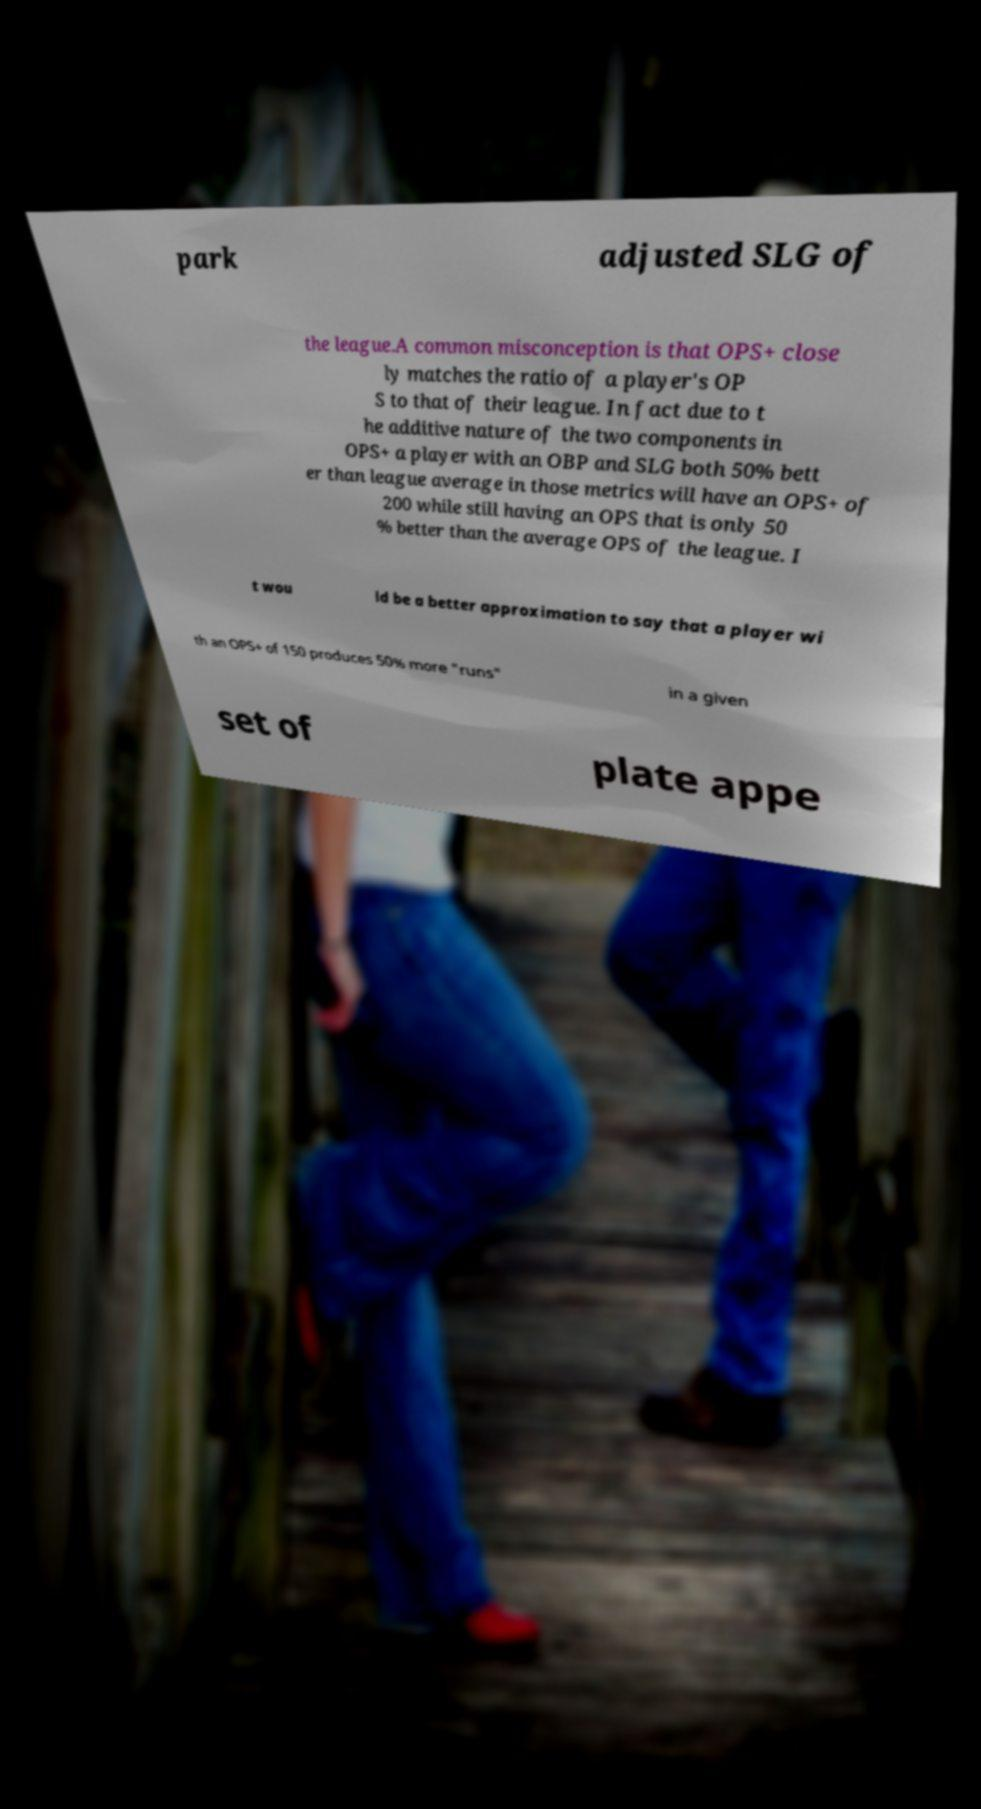Please read and relay the text visible in this image. What does it say? park adjusted SLG of the league.A common misconception is that OPS+ close ly matches the ratio of a player's OP S to that of their league. In fact due to t he additive nature of the two components in OPS+ a player with an OBP and SLG both 50% bett er than league average in those metrics will have an OPS+ of 200 while still having an OPS that is only 50 % better than the average OPS of the league. I t wou ld be a better approximation to say that a player wi th an OPS+ of 150 produces 50% more "runs" in a given set of plate appe 